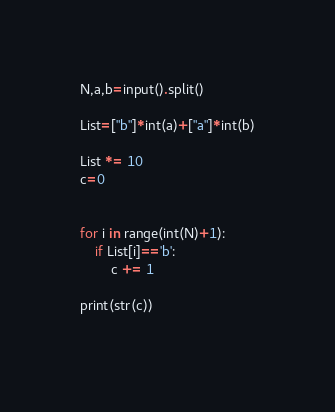Convert code to text. <code><loc_0><loc_0><loc_500><loc_500><_Python_>N,a,b=input().split()

List=["b"]*int(a)+["a"]*int(b)

List *= 10
c=0


for i in range(int(N)+1):
    if List[i]=='b':
        c += 1
        
print(str(c))
        
</code> 